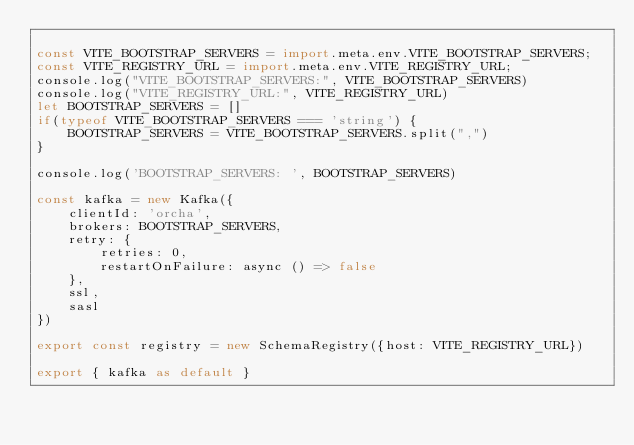<code> <loc_0><loc_0><loc_500><loc_500><_TypeScript_>
const VITE_BOOTSTRAP_SERVERS = import.meta.env.VITE_BOOTSTRAP_SERVERS;
const VITE_REGISTRY_URL = import.meta.env.VITE_REGISTRY_URL;
console.log("VITE_BOOTSTRAP_SERVERS:", VITE_BOOTSTRAP_SERVERS)
console.log("VITE_REGISTRY_URL:", VITE_REGISTRY_URL)
let BOOTSTRAP_SERVERS = []
if(typeof VITE_BOOTSTRAP_SERVERS === 'string') {
    BOOTSTRAP_SERVERS = VITE_BOOTSTRAP_SERVERS.split(",")
}

console.log('BOOTSTRAP_SERVERS: ', BOOTSTRAP_SERVERS)

const kafka = new Kafka({
    clientId: 'orcha',
    brokers: BOOTSTRAP_SERVERS,
    retry: {
        retries: 0,
        restartOnFailure: async () => false
    },
    ssl,
    sasl
})

export const registry = new SchemaRegistry({host: VITE_REGISTRY_URL})

export { kafka as default }</code> 